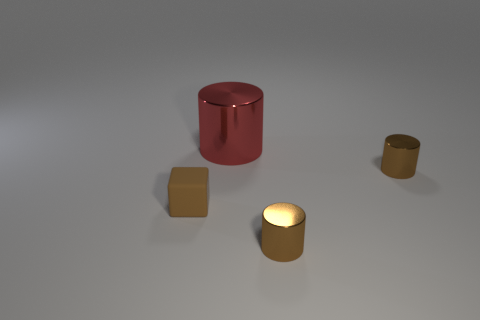Is there any other thing that is the same size as the red object?
Make the answer very short. No. Is there any other thing that has the same material as the brown cube?
Your answer should be very brief. No. Are there any big rubber balls that have the same color as the matte object?
Provide a succinct answer. No. There is a brown cube left of the tiny metal object that is behind the tiny brown thing that is on the left side of the red cylinder; what size is it?
Your answer should be very brief. Small. Do the brown rubber thing and the tiny brown metal thing behind the tiny matte thing have the same shape?
Offer a terse response. No. What number of other objects are the same size as the brown rubber object?
Your answer should be very brief. 2. There is a object that is to the left of the large red cylinder; what is its size?
Provide a succinct answer. Small. How many big red objects have the same material as the cube?
Offer a very short reply. 0. Does the tiny thing that is on the left side of the large metallic cylinder have the same shape as the big metal object?
Your answer should be very brief. No. What is the shape of the brown object behind the tiny brown matte thing?
Your answer should be compact. Cylinder. 